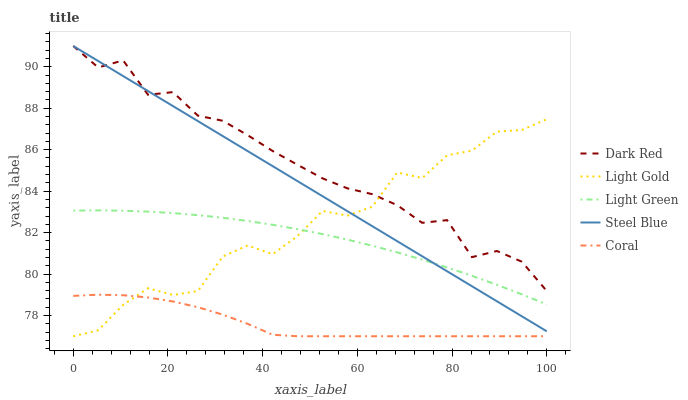Does Coral have the minimum area under the curve?
Answer yes or no. Yes. Does Dark Red have the maximum area under the curve?
Answer yes or no. Yes. Does Light Gold have the minimum area under the curve?
Answer yes or no. No. Does Light Gold have the maximum area under the curve?
Answer yes or no. No. Is Steel Blue the smoothest?
Answer yes or no. Yes. Is Light Gold the roughest?
Answer yes or no. Yes. Is Coral the smoothest?
Answer yes or no. No. Is Coral the roughest?
Answer yes or no. No. Does Coral have the lowest value?
Answer yes or no. Yes. Does Steel Blue have the lowest value?
Answer yes or no. No. Does Steel Blue have the highest value?
Answer yes or no. Yes. Does Light Gold have the highest value?
Answer yes or no. No. Is Light Green less than Dark Red?
Answer yes or no. Yes. Is Light Green greater than Coral?
Answer yes or no. Yes. Does Light Gold intersect Dark Red?
Answer yes or no. Yes. Is Light Gold less than Dark Red?
Answer yes or no. No. Is Light Gold greater than Dark Red?
Answer yes or no. No. Does Light Green intersect Dark Red?
Answer yes or no. No. 